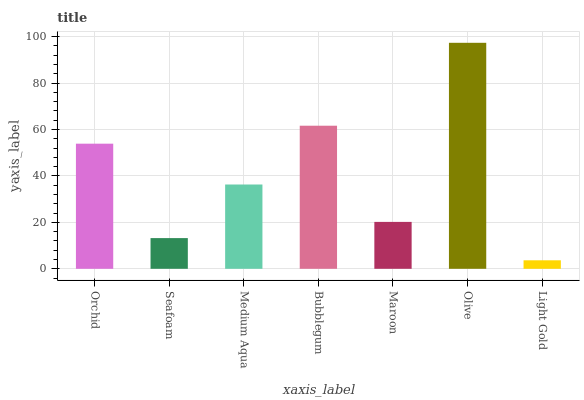Is Light Gold the minimum?
Answer yes or no. Yes. Is Olive the maximum?
Answer yes or no. Yes. Is Seafoam the minimum?
Answer yes or no. No. Is Seafoam the maximum?
Answer yes or no. No. Is Orchid greater than Seafoam?
Answer yes or no. Yes. Is Seafoam less than Orchid?
Answer yes or no. Yes. Is Seafoam greater than Orchid?
Answer yes or no. No. Is Orchid less than Seafoam?
Answer yes or no. No. Is Medium Aqua the high median?
Answer yes or no. Yes. Is Medium Aqua the low median?
Answer yes or no. Yes. Is Bubblegum the high median?
Answer yes or no. No. Is Light Gold the low median?
Answer yes or no. No. 